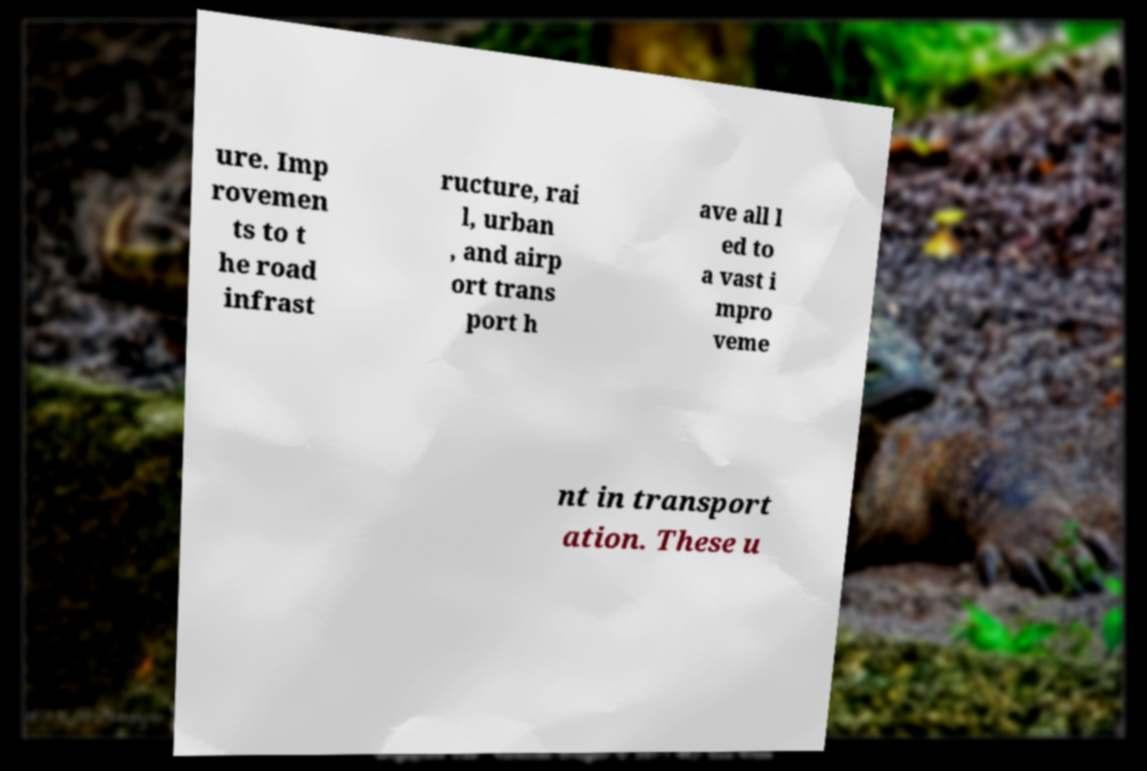Could you extract and type out the text from this image? ure. Imp rovemen ts to t he road infrast ructure, rai l, urban , and airp ort trans port h ave all l ed to a vast i mpro veme nt in transport ation. These u 